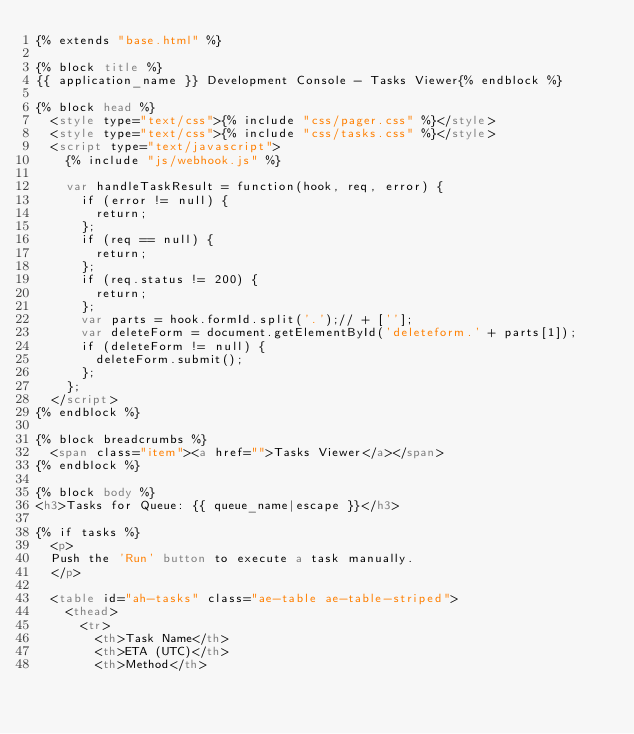<code> <loc_0><loc_0><loc_500><loc_500><_HTML_>{% extends "base.html" %}

{% block title %}
{{ application_name }} Development Console - Tasks Viewer{% endblock %}

{% block head %}
  <style type="text/css">{% include "css/pager.css" %}</style>
  <style type="text/css">{% include "css/tasks.css" %}</style>
  <script type="text/javascript">
    {% include "js/webhook.js" %}

    var handleTaskResult = function(hook, req, error) {
      if (error != null) {
        return;
      };
      if (req == null) {
        return;
      };
      if (req.status != 200) {
        return;
      };
      var parts = hook.formId.split('.');// + [''];
      var deleteForm = document.getElementById('deleteform.' + parts[1]);
      if (deleteForm != null) {
        deleteForm.submit();
      };
    };
  </script>
{% endblock %}

{% block breadcrumbs %}
  <span class="item"><a href="">Tasks Viewer</a></span>
{% endblock %}

{% block body %}
<h3>Tasks for Queue: {{ queue_name|escape }}</h3>

{% if tasks %}
  <p>
  Push the 'Run' button to execute a task manually.
  </p>

  <table id="ah-tasks" class="ae-table ae-table-striped">
    <thead>
      <tr>
        <th>Task Name</th>
        <th>ETA (UTC)</th>
        <th>Method</th></code> 